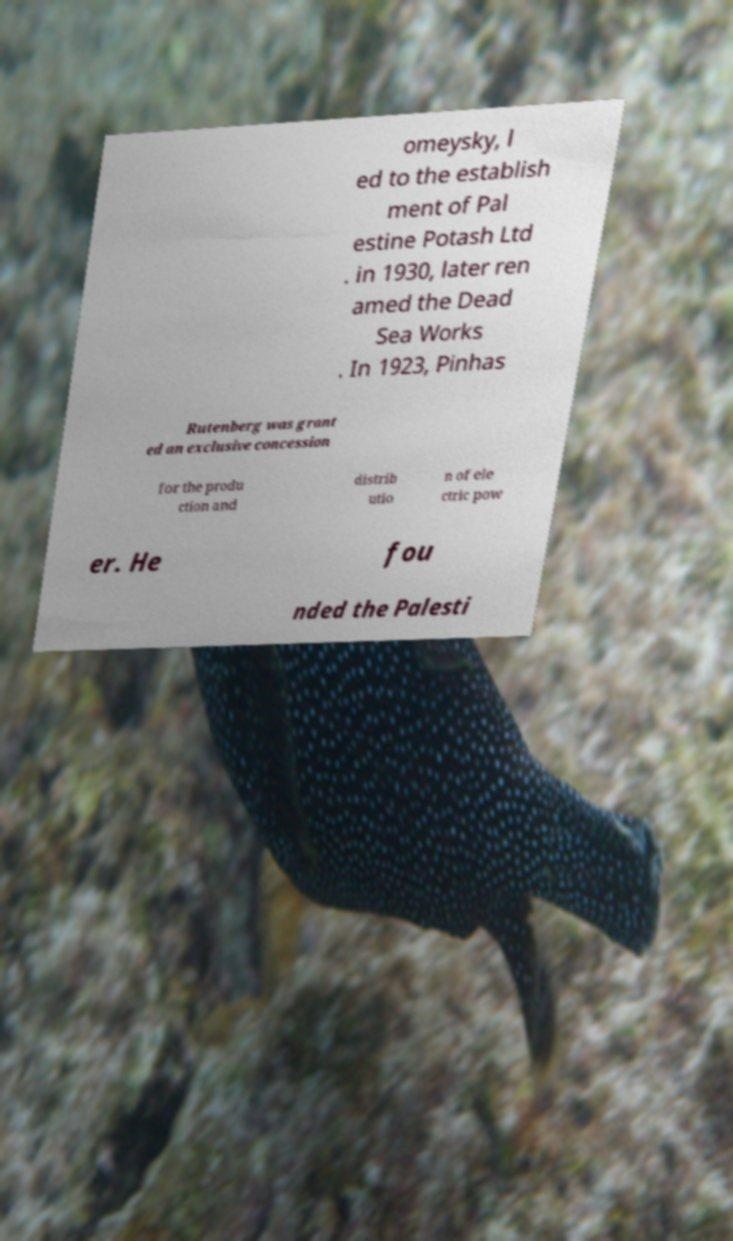What messages or text are displayed in this image? I need them in a readable, typed format. omeysky, l ed to the establish ment of Pal estine Potash Ltd . in 1930, later ren amed the Dead Sea Works . In 1923, Pinhas Rutenberg was grant ed an exclusive concession for the produ ction and distrib utio n of ele ctric pow er. He fou nded the Palesti 